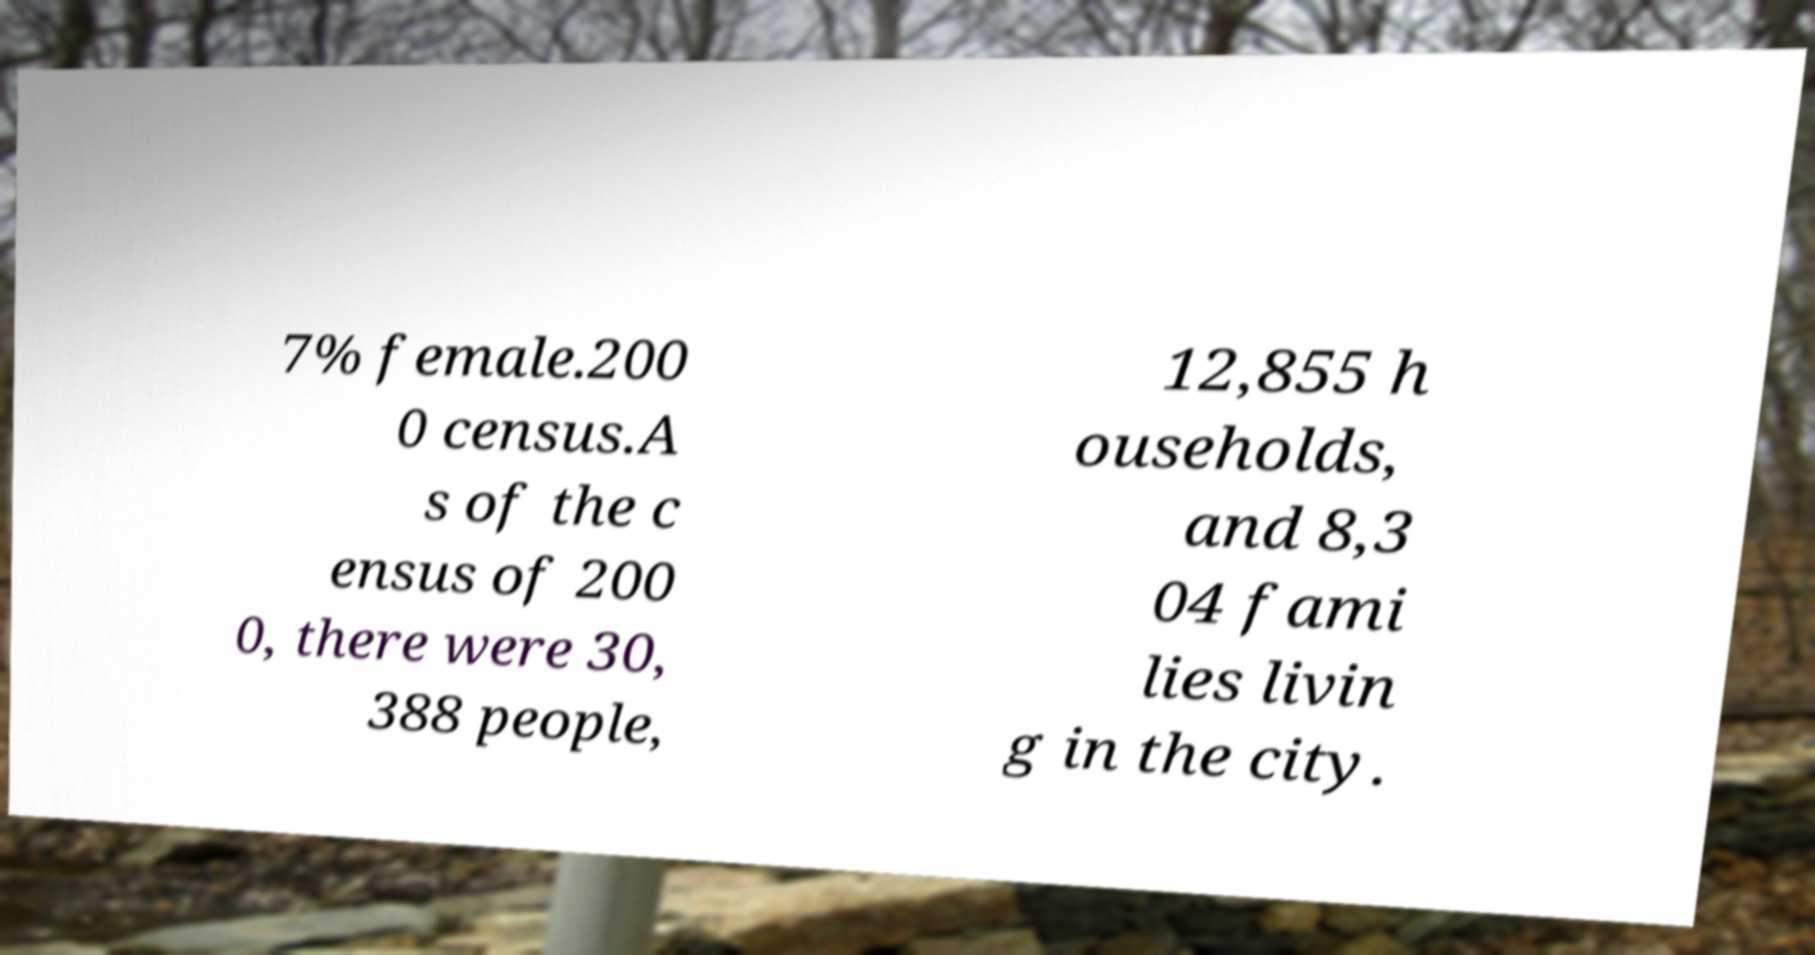What messages or text are displayed in this image? I need them in a readable, typed format. 7% female.200 0 census.A s of the c ensus of 200 0, there were 30, 388 people, 12,855 h ouseholds, and 8,3 04 fami lies livin g in the city. 